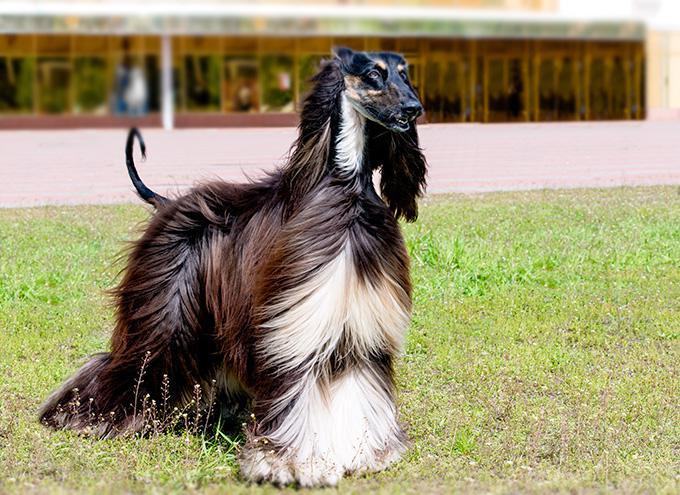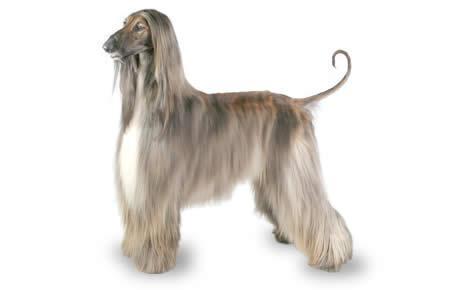The first image is the image on the left, the second image is the image on the right. Given the left and right images, does the statement "In one image there is a lone afghan hound standing outside and facing the left side of the image." hold true? Answer yes or no. No. The first image is the image on the left, the second image is the image on the right. Considering the images on both sides, is "At least one image is of a dog from the shoulders up, looking toward the camera." valid? Answer yes or no. No. 